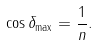<formula> <loc_0><loc_0><loc_500><loc_500>\cos \delta _ { \max } = \frac { 1 } { n } .</formula> 